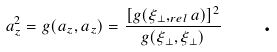Convert formula to latex. <formula><loc_0><loc_0><loc_500><loc_500>a _ { z } ^ { 2 } = g ( a _ { z } , a _ { z } ) = \frac { [ g ( \xi _ { \perp } , _ { r e l } a ) ] ^ { 2 } } { g ( \xi _ { \perp } , \xi _ { \perp } ) } \text { \quad .}</formula> 